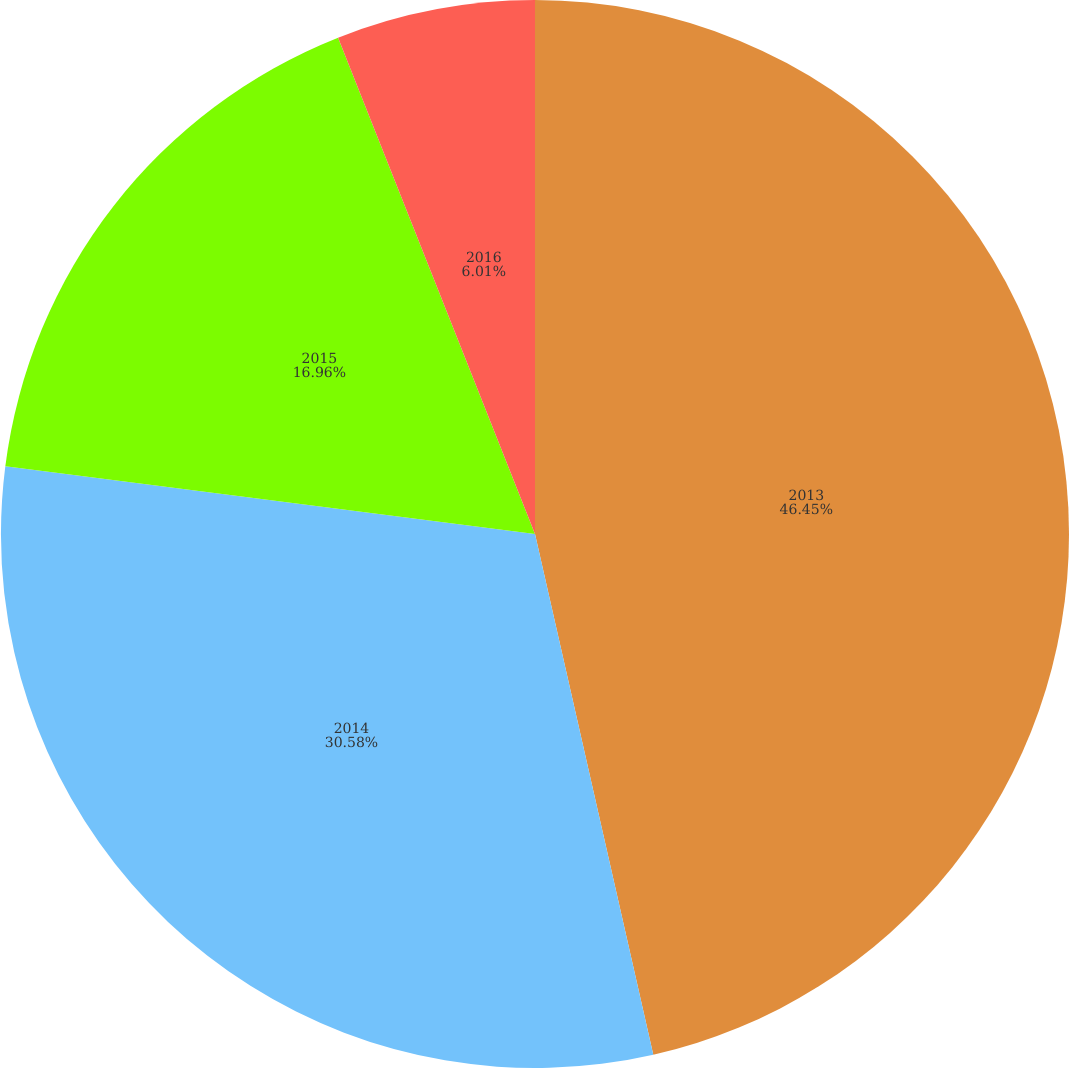Convert chart. <chart><loc_0><loc_0><loc_500><loc_500><pie_chart><fcel>2013<fcel>2014<fcel>2015<fcel>2016<nl><fcel>46.44%<fcel>30.58%<fcel>16.96%<fcel>6.01%<nl></chart> 